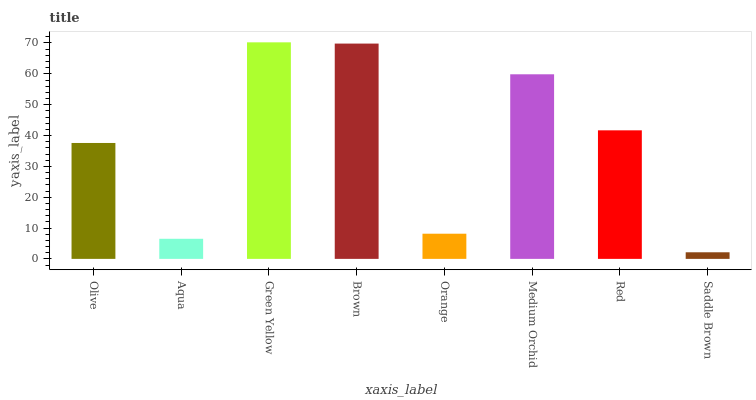Is Saddle Brown the minimum?
Answer yes or no. Yes. Is Green Yellow the maximum?
Answer yes or no. Yes. Is Aqua the minimum?
Answer yes or no. No. Is Aqua the maximum?
Answer yes or no. No. Is Olive greater than Aqua?
Answer yes or no. Yes. Is Aqua less than Olive?
Answer yes or no. Yes. Is Aqua greater than Olive?
Answer yes or no. No. Is Olive less than Aqua?
Answer yes or no. No. Is Red the high median?
Answer yes or no. Yes. Is Olive the low median?
Answer yes or no. Yes. Is Saddle Brown the high median?
Answer yes or no. No. Is Green Yellow the low median?
Answer yes or no. No. 